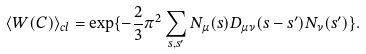Convert formula to latex. <formula><loc_0><loc_0><loc_500><loc_500>\langle W ( C ) \rangle _ { c l } = \exp \{ - \frac { 2 } { 3 } \pi ^ { 2 } \sum _ { s , s ^ { \prime } } N _ { \mu } ( s ) D _ { \mu \nu } ( s - s ^ { \prime } ) N _ { \nu } ( s ^ { \prime } ) \} .</formula> 